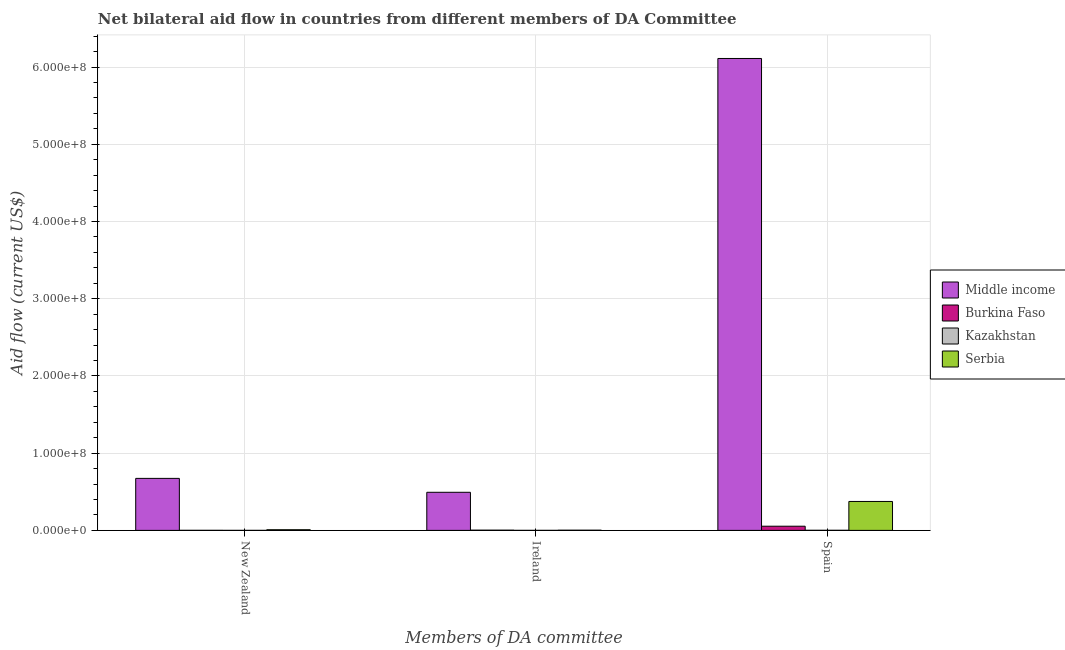Are the number of bars per tick equal to the number of legend labels?
Your response must be concise. Yes. What is the label of the 2nd group of bars from the left?
Ensure brevity in your answer.  Ireland. What is the amount of aid provided by spain in Burkina Faso?
Your answer should be very brief. 5.42e+06. Across all countries, what is the maximum amount of aid provided by spain?
Give a very brief answer. 6.11e+08. Across all countries, what is the minimum amount of aid provided by ireland?
Your answer should be compact. 2.00e+04. In which country was the amount of aid provided by new zealand minimum?
Ensure brevity in your answer.  Kazakhstan. What is the total amount of aid provided by ireland in the graph?
Give a very brief answer. 4.99e+07. What is the difference between the amount of aid provided by ireland in Serbia and that in Kazakhstan?
Keep it short and to the point. 2.40e+05. What is the difference between the amount of aid provided by new zealand in Serbia and the amount of aid provided by ireland in Burkina Faso?
Offer a terse response. 5.50e+05. What is the average amount of aid provided by new zealand per country?
Your response must be concise. 1.71e+07. What is the difference between the amount of aid provided by spain and amount of aid provided by ireland in Middle income?
Keep it short and to the point. 5.62e+08. In how many countries, is the amount of aid provided by new zealand greater than 180000000 US$?
Your response must be concise. 0. What is the ratio of the amount of aid provided by ireland in Burkina Faso to that in Kazakhstan?
Give a very brief answer. 15. Is the amount of aid provided by ireland in Middle income less than that in Kazakhstan?
Your response must be concise. No. What is the difference between the highest and the second highest amount of aid provided by spain?
Your answer should be very brief. 5.74e+08. What is the difference between the highest and the lowest amount of aid provided by ireland?
Your response must be concise. 4.93e+07. What does the 3rd bar from the left in Spain represents?
Provide a short and direct response. Kazakhstan. What does the 2nd bar from the right in Spain represents?
Ensure brevity in your answer.  Kazakhstan. How many bars are there?
Your answer should be very brief. 12. Are all the bars in the graph horizontal?
Provide a short and direct response. No. How many countries are there in the graph?
Offer a terse response. 4. Are the values on the major ticks of Y-axis written in scientific E-notation?
Make the answer very short. Yes. Does the graph contain grids?
Give a very brief answer. Yes. Where does the legend appear in the graph?
Give a very brief answer. Center right. How are the legend labels stacked?
Offer a terse response. Vertical. What is the title of the graph?
Provide a succinct answer. Net bilateral aid flow in countries from different members of DA Committee. Does "Ghana" appear as one of the legend labels in the graph?
Keep it short and to the point. No. What is the label or title of the X-axis?
Your response must be concise. Members of DA committee. What is the label or title of the Y-axis?
Provide a short and direct response. Aid flow (current US$). What is the Aid flow (current US$) in Middle income in New Zealand?
Make the answer very short. 6.74e+07. What is the Aid flow (current US$) in Serbia in New Zealand?
Offer a very short reply. 8.50e+05. What is the Aid flow (current US$) in Middle income in Ireland?
Provide a short and direct response. 4.93e+07. What is the Aid flow (current US$) in Kazakhstan in Ireland?
Your answer should be very brief. 2.00e+04. What is the Aid flow (current US$) in Middle income in Spain?
Offer a terse response. 6.11e+08. What is the Aid flow (current US$) of Burkina Faso in Spain?
Your answer should be very brief. 5.42e+06. What is the Aid flow (current US$) in Kazakhstan in Spain?
Offer a terse response. 1.20e+05. What is the Aid flow (current US$) of Serbia in Spain?
Keep it short and to the point. 3.75e+07. Across all Members of DA committee, what is the maximum Aid flow (current US$) of Middle income?
Offer a very short reply. 6.11e+08. Across all Members of DA committee, what is the maximum Aid flow (current US$) of Burkina Faso?
Your response must be concise. 5.42e+06. Across all Members of DA committee, what is the maximum Aid flow (current US$) in Serbia?
Keep it short and to the point. 3.75e+07. Across all Members of DA committee, what is the minimum Aid flow (current US$) in Middle income?
Provide a succinct answer. 4.93e+07. Across all Members of DA committee, what is the minimum Aid flow (current US$) of Serbia?
Offer a terse response. 2.60e+05. What is the total Aid flow (current US$) in Middle income in the graph?
Ensure brevity in your answer.  7.28e+08. What is the total Aid flow (current US$) of Burkina Faso in the graph?
Offer a terse response. 5.79e+06. What is the total Aid flow (current US$) of Serbia in the graph?
Keep it short and to the point. 3.86e+07. What is the difference between the Aid flow (current US$) in Middle income in New Zealand and that in Ireland?
Your answer should be very brief. 1.80e+07. What is the difference between the Aid flow (current US$) in Burkina Faso in New Zealand and that in Ireland?
Your response must be concise. -2.30e+05. What is the difference between the Aid flow (current US$) in Serbia in New Zealand and that in Ireland?
Give a very brief answer. 5.90e+05. What is the difference between the Aid flow (current US$) of Middle income in New Zealand and that in Spain?
Give a very brief answer. -5.44e+08. What is the difference between the Aid flow (current US$) of Burkina Faso in New Zealand and that in Spain?
Offer a terse response. -5.35e+06. What is the difference between the Aid flow (current US$) of Kazakhstan in New Zealand and that in Spain?
Provide a succinct answer. -1.10e+05. What is the difference between the Aid flow (current US$) in Serbia in New Zealand and that in Spain?
Provide a short and direct response. -3.66e+07. What is the difference between the Aid flow (current US$) of Middle income in Ireland and that in Spain?
Offer a terse response. -5.62e+08. What is the difference between the Aid flow (current US$) of Burkina Faso in Ireland and that in Spain?
Keep it short and to the point. -5.12e+06. What is the difference between the Aid flow (current US$) of Serbia in Ireland and that in Spain?
Provide a succinct answer. -3.72e+07. What is the difference between the Aid flow (current US$) in Middle income in New Zealand and the Aid flow (current US$) in Burkina Faso in Ireland?
Provide a succinct answer. 6.71e+07. What is the difference between the Aid flow (current US$) in Middle income in New Zealand and the Aid flow (current US$) in Kazakhstan in Ireland?
Offer a very short reply. 6.73e+07. What is the difference between the Aid flow (current US$) in Middle income in New Zealand and the Aid flow (current US$) in Serbia in Ireland?
Make the answer very short. 6.71e+07. What is the difference between the Aid flow (current US$) of Burkina Faso in New Zealand and the Aid flow (current US$) of Kazakhstan in Ireland?
Your answer should be compact. 5.00e+04. What is the difference between the Aid flow (current US$) in Kazakhstan in New Zealand and the Aid flow (current US$) in Serbia in Ireland?
Provide a short and direct response. -2.50e+05. What is the difference between the Aid flow (current US$) in Middle income in New Zealand and the Aid flow (current US$) in Burkina Faso in Spain?
Your answer should be very brief. 6.19e+07. What is the difference between the Aid flow (current US$) in Middle income in New Zealand and the Aid flow (current US$) in Kazakhstan in Spain?
Your answer should be compact. 6.72e+07. What is the difference between the Aid flow (current US$) in Middle income in New Zealand and the Aid flow (current US$) in Serbia in Spain?
Keep it short and to the point. 2.99e+07. What is the difference between the Aid flow (current US$) in Burkina Faso in New Zealand and the Aid flow (current US$) in Kazakhstan in Spain?
Your response must be concise. -5.00e+04. What is the difference between the Aid flow (current US$) of Burkina Faso in New Zealand and the Aid flow (current US$) of Serbia in Spain?
Your response must be concise. -3.74e+07. What is the difference between the Aid flow (current US$) of Kazakhstan in New Zealand and the Aid flow (current US$) of Serbia in Spain?
Keep it short and to the point. -3.74e+07. What is the difference between the Aid flow (current US$) of Middle income in Ireland and the Aid flow (current US$) of Burkina Faso in Spain?
Ensure brevity in your answer.  4.39e+07. What is the difference between the Aid flow (current US$) in Middle income in Ireland and the Aid flow (current US$) in Kazakhstan in Spain?
Offer a very short reply. 4.92e+07. What is the difference between the Aid flow (current US$) of Middle income in Ireland and the Aid flow (current US$) of Serbia in Spain?
Keep it short and to the point. 1.19e+07. What is the difference between the Aid flow (current US$) of Burkina Faso in Ireland and the Aid flow (current US$) of Kazakhstan in Spain?
Give a very brief answer. 1.80e+05. What is the difference between the Aid flow (current US$) of Burkina Faso in Ireland and the Aid flow (current US$) of Serbia in Spain?
Your answer should be compact. -3.72e+07. What is the difference between the Aid flow (current US$) in Kazakhstan in Ireland and the Aid flow (current US$) in Serbia in Spain?
Provide a short and direct response. -3.74e+07. What is the average Aid flow (current US$) in Middle income per Members of DA committee?
Give a very brief answer. 2.43e+08. What is the average Aid flow (current US$) of Burkina Faso per Members of DA committee?
Your response must be concise. 1.93e+06. What is the average Aid flow (current US$) in Kazakhstan per Members of DA committee?
Your answer should be compact. 5.00e+04. What is the average Aid flow (current US$) of Serbia per Members of DA committee?
Your answer should be very brief. 1.29e+07. What is the difference between the Aid flow (current US$) in Middle income and Aid flow (current US$) in Burkina Faso in New Zealand?
Keep it short and to the point. 6.73e+07. What is the difference between the Aid flow (current US$) in Middle income and Aid flow (current US$) in Kazakhstan in New Zealand?
Your answer should be very brief. 6.74e+07. What is the difference between the Aid flow (current US$) of Middle income and Aid flow (current US$) of Serbia in New Zealand?
Ensure brevity in your answer.  6.65e+07. What is the difference between the Aid flow (current US$) of Burkina Faso and Aid flow (current US$) of Serbia in New Zealand?
Your answer should be compact. -7.80e+05. What is the difference between the Aid flow (current US$) of Kazakhstan and Aid flow (current US$) of Serbia in New Zealand?
Ensure brevity in your answer.  -8.40e+05. What is the difference between the Aid flow (current US$) in Middle income and Aid flow (current US$) in Burkina Faso in Ireland?
Your answer should be very brief. 4.90e+07. What is the difference between the Aid flow (current US$) of Middle income and Aid flow (current US$) of Kazakhstan in Ireland?
Make the answer very short. 4.93e+07. What is the difference between the Aid flow (current US$) in Middle income and Aid flow (current US$) in Serbia in Ireland?
Your response must be concise. 4.91e+07. What is the difference between the Aid flow (current US$) of Kazakhstan and Aid flow (current US$) of Serbia in Ireland?
Your response must be concise. -2.40e+05. What is the difference between the Aid flow (current US$) of Middle income and Aid flow (current US$) of Burkina Faso in Spain?
Keep it short and to the point. 6.06e+08. What is the difference between the Aid flow (current US$) of Middle income and Aid flow (current US$) of Kazakhstan in Spain?
Provide a short and direct response. 6.11e+08. What is the difference between the Aid flow (current US$) of Middle income and Aid flow (current US$) of Serbia in Spain?
Provide a short and direct response. 5.74e+08. What is the difference between the Aid flow (current US$) of Burkina Faso and Aid flow (current US$) of Kazakhstan in Spain?
Ensure brevity in your answer.  5.30e+06. What is the difference between the Aid flow (current US$) of Burkina Faso and Aid flow (current US$) of Serbia in Spain?
Your response must be concise. -3.20e+07. What is the difference between the Aid flow (current US$) in Kazakhstan and Aid flow (current US$) in Serbia in Spain?
Keep it short and to the point. -3.73e+07. What is the ratio of the Aid flow (current US$) in Middle income in New Zealand to that in Ireland?
Your answer should be compact. 1.37. What is the ratio of the Aid flow (current US$) in Burkina Faso in New Zealand to that in Ireland?
Offer a very short reply. 0.23. What is the ratio of the Aid flow (current US$) of Kazakhstan in New Zealand to that in Ireland?
Give a very brief answer. 0.5. What is the ratio of the Aid flow (current US$) in Serbia in New Zealand to that in Ireland?
Ensure brevity in your answer.  3.27. What is the ratio of the Aid flow (current US$) in Middle income in New Zealand to that in Spain?
Offer a terse response. 0.11. What is the ratio of the Aid flow (current US$) in Burkina Faso in New Zealand to that in Spain?
Provide a short and direct response. 0.01. What is the ratio of the Aid flow (current US$) in Kazakhstan in New Zealand to that in Spain?
Make the answer very short. 0.08. What is the ratio of the Aid flow (current US$) of Serbia in New Zealand to that in Spain?
Keep it short and to the point. 0.02. What is the ratio of the Aid flow (current US$) in Middle income in Ireland to that in Spain?
Your response must be concise. 0.08. What is the ratio of the Aid flow (current US$) of Burkina Faso in Ireland to that in Spain?
Provide a succinct answer. 0.06. What is the ratio of the Aid flow (current US$) in Kazakhstan in Ireland to that in Spain?
Provide a succinct answer. 0.17. What is the ratio of the Aid flow (current US$) of Serbia in Ireland to that in Spain?
Your answer should be very brief. 0.01. What is the difference between the highest and the second highest Aid flow (current US$) in Middle income?
Your answer should be compact. 5.44e+08. What is the difference between the highest and the second highest Aid flow (current US$) in Burkina Faso?
Keep it short and to the point. 5.12e+06. What is the difference between the highest and the second highest Aid flow (current US$) in Serbia?
Your answer should be very brief. 3.66e+07. What is the difference between the highest and the lowest Aid flow (current US$) of Middle income?
Provide a short and direct response. 5.62e+08. What is the difference between the highest and the lowest Aid flow (current US$) of Burkina Faso?
Make the answer very short. 5.35e+06. What is the difference between the highest and the lowest Aid flow (current US$) in Kazakhstan?
Your answer should be very brief. 1.10e+05. What is the difference between the highest and the lowest Aid flow (current US$) in Serbia?
Your answer should be very brief. 3.72e+07. 